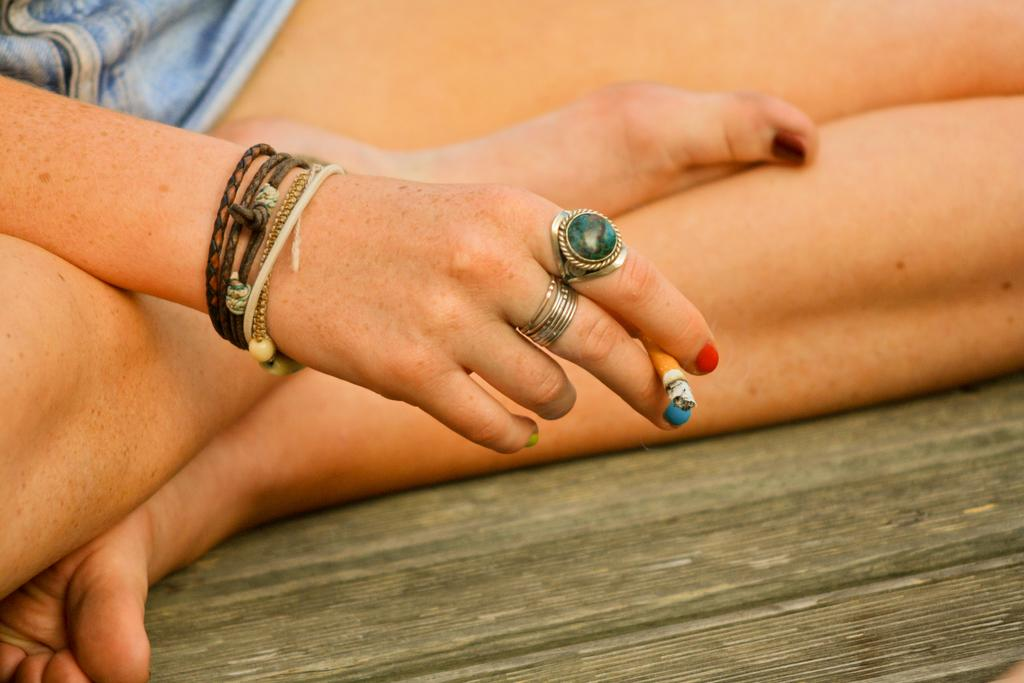What part of a person's body is visible in the image? There is a person's hand in the image. What else can be seen of the person's body? The person's legs are visible in the image. Are there any accessories on the person's fingers? Yes, there are two rings on the person's fingers. What type of road can be seen in the image? There is no road visible in the image; it only shows a person's hand and legs. How many houses are present in the image? There are no houses present in the image; it only shows a person's hand and legs. 